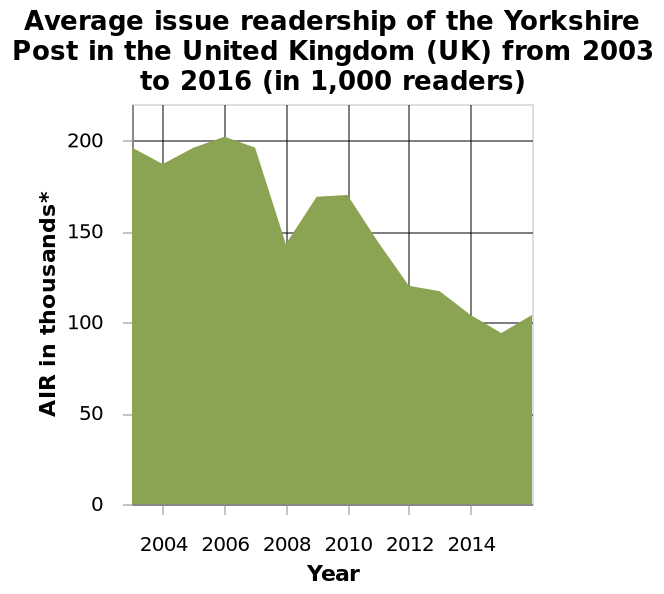<image>
What is the type of chart used to represent the average annual wages in Slovak Republic from 2000 to 2019? The chart used is an area chart. What was the average number of readers from 2003 to 2007?  The average number of readers from 2003 to 2007 was 200 thousand. What unit of measurement is used for the average issue readership on the y-axis? The average issue readership is measured in thousands of readers. 